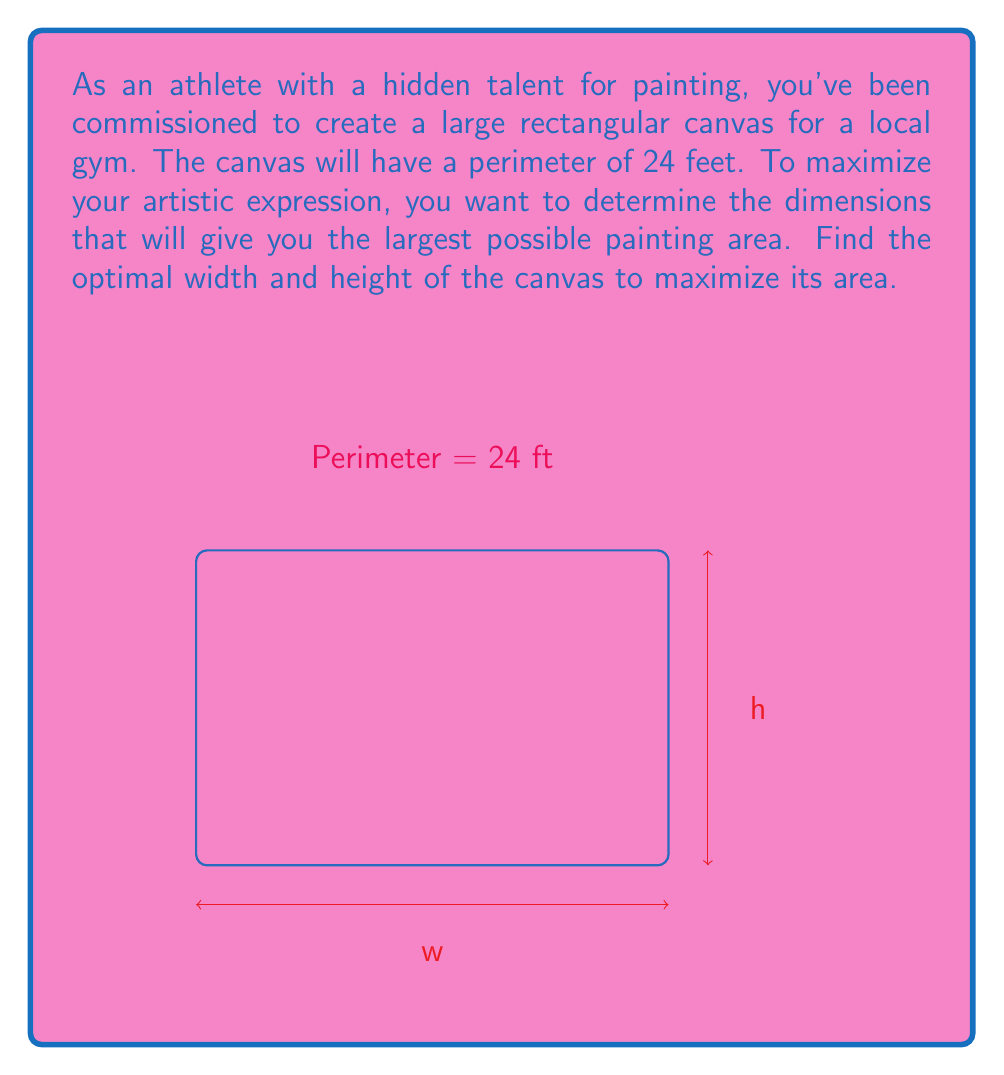Teach me how to tackle this problem. Let's approach this step-by-step:

1) Let $w$ be the width and $h$ be the height of the canvas.

2) Given that the perimeter is 24 feet, we can write:
   $$2w + 2h = 24$$

3) Solving for $h$:
   $$h = 12 - w$$

4) The area $A$ of the canvas is given by $A = wh$. Substituting $h$:
   $$A = w(12-w) = 12w - w^2$$

5) To find the maximum area, we need to find the vertex of this quadratic function. We can do this by finding where the derivative equals zero:
   $$\frac{dA}{dw} = 12 - 2w$$

6) Setting this equal to zero:
   $$12 - 2w = 0$$
   $$2w = 12$$
   $$w = 6$$

7) Since the second derivative $\frac{d^2A}{dw^2} = -2$ is negative, this critical point is a maximum.

8) With $w = 6$, we can find $h$:
   $$h = 12 - w = 12 - 6 = 6$$

9) Therefore, the optimal dimensions are 6 feet by 6 feet.

10) The maximum area is:
    $$A = 6 * 6 = 36$$ square feet.
Answer: $w = 6$ ft, $h = 6$ ft; max area = $36$ sq ft 